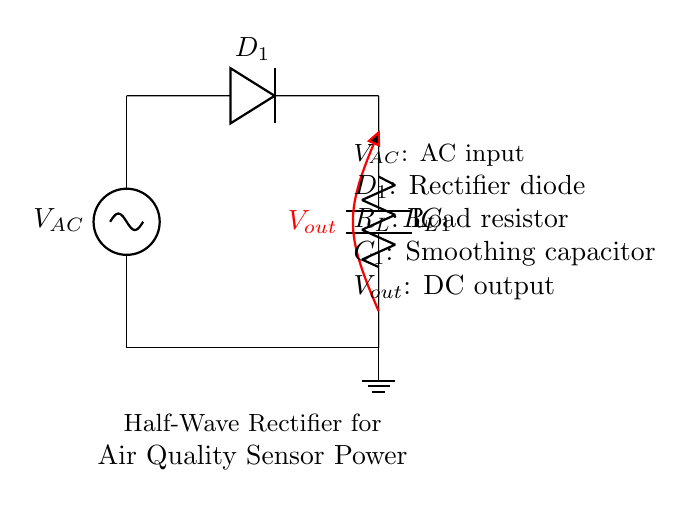What type of rectifier is this circuit? This is a half-wave rectifier, indicated by the presence of a single diode allowing current flow in only one direction.
Answer: half-wave rectifier What is the function of the diode? The diode, labeled D1, rectifies the alternating current by allowing positive voltage to pass while blocking negative voltage.
Answer: rectify current What is the purpose of the capacitor in this circuit? The capacitor, labeled C1, smooths out the rectified output voltage by reducing ripples in the DC output, providing a steadier voltage.
Answer: smooth output What happens to the output voltage during the negative cycle of the AC input? During the negative cycle of the AC input, the output voltage is zero because the diode blocks the flow, preventing any current from reaching the load.
Answer: zero voltage How does the load resistor affect the circuit? The load resistor, labeled R_L, determines the amount of current drawn from the output; its value affects the voltage drop across it and impacts the overall efficiency of power delivery to the sensors.
Answer: affects current What would be the impact of using a higher capacitance for C1? A higher capacitance would increase the smoothing effect, resulting in a less pulsating DC output and potentially improving the performance of the air quality sensors by providing a more stable voltage level.
Answer: improved stability What is the output voltage labeled as? The output voltage is labeled V_out, which represents the voltage available to power the air quality sensors after rectification and smoothing.
Answer: V_out 